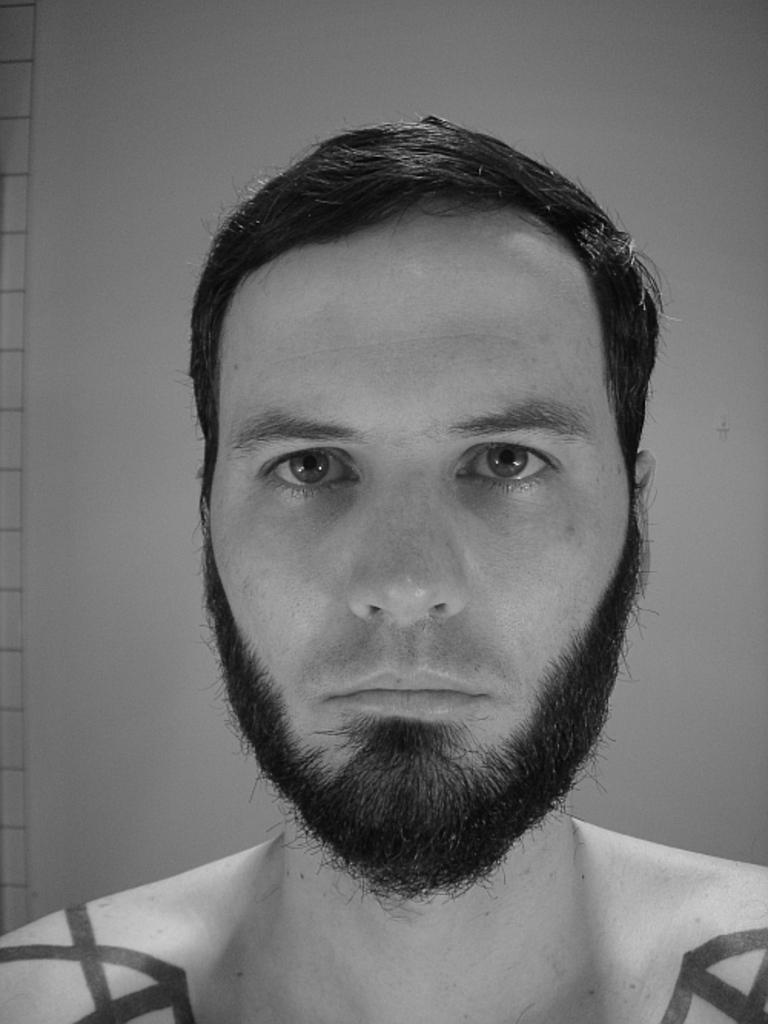What is the color scheme of the image? The image is black and white. Who is present in the image? There is a man in the image. What is the man doing in the image? The man is looking at a picture. Are there any other notable features on the man? Yes, there are paintings on the man's shoulders. What can be seen in the background of the image? There is a wall in the background of the image. What type of chicken is depicted in the image? There is no chicken present in the image. What is the man's belief about the picture he is looking at? The image does not provide any information about the man's beliefs or opinions regarding the picture he is looking at. 